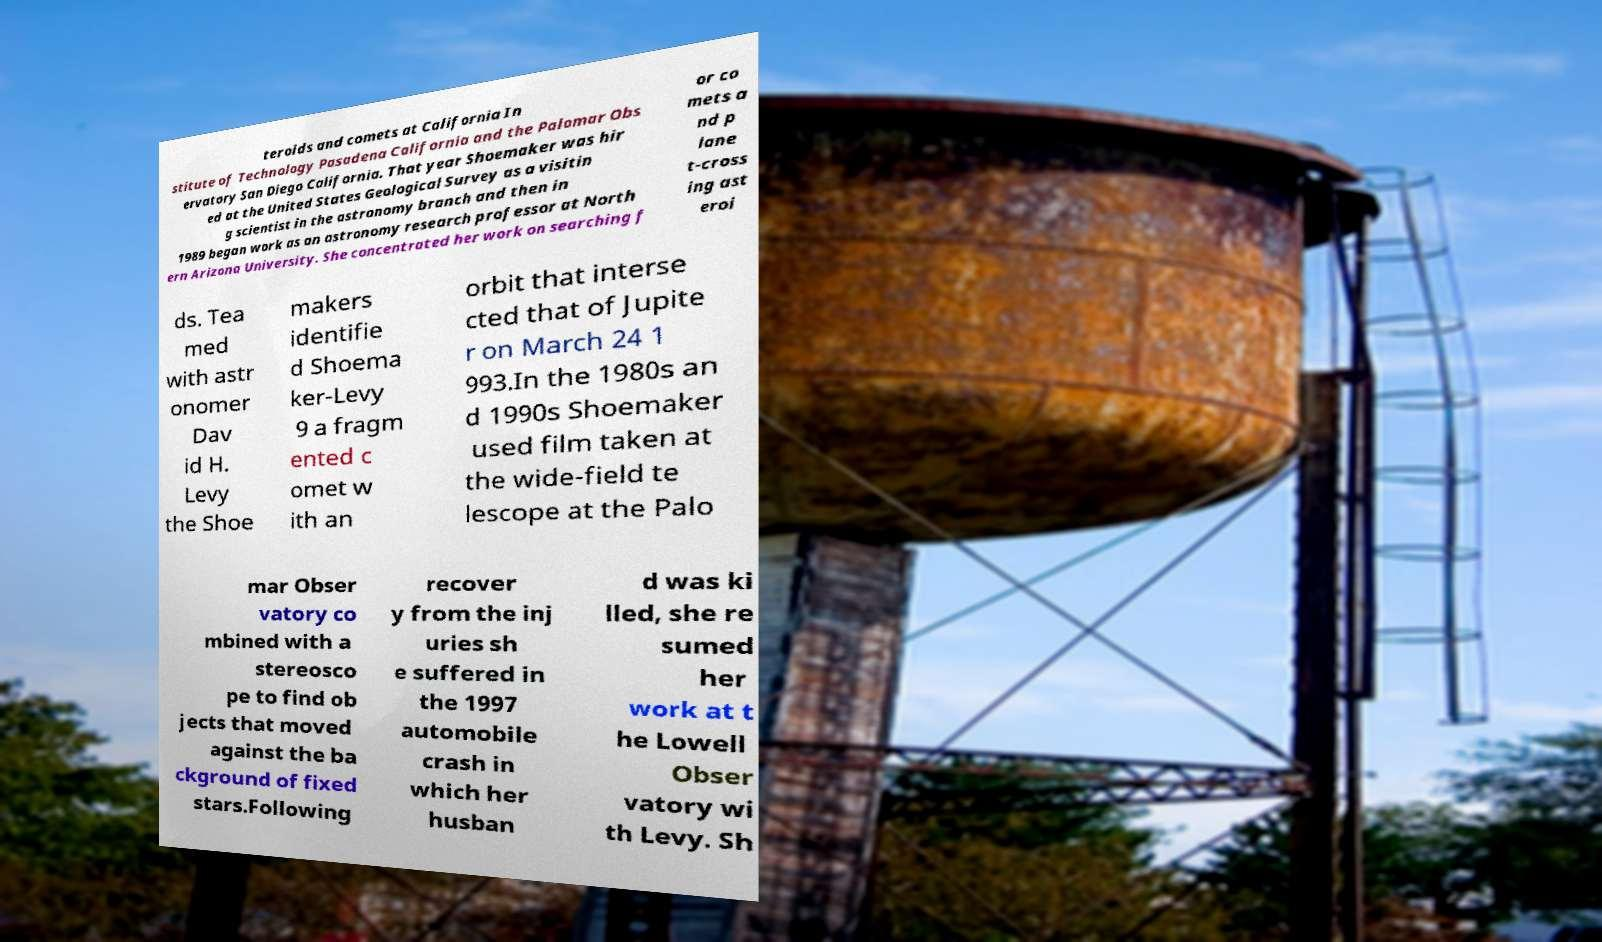Can you read and provide the text displayed in the image?This photo seems to have some interesting text. Can you extract and type it out for me? teroids and comets at California In stitute of Technology Pasadena California and the Palomar Obs ervatory San Diego California. That year Shoemaker was hir ed at the United States Geological Survey as a visitin g scientist in the astronomy branch and then in 1989 began work as an astronomy research professor at North ern Arizona University. She concentrated her work on searching f or co mets a nd p lane t-cross ing ast eroi ds. Tea med with astr onomer Dav id H. Levy the Shoe makers identifie d Shoema ker-Levy 9 a fragm ented c omet w ith an orbit that interse cted that of Jupite r on March 24 1 993.In the 1980s an d 1990s Shoemaker used film taken at the wide-field te lescope at the Palo mar Obser vatory co mbined with a stereosco pe to find ob jects that moved against the ba ckground of fixed stars.Following recover y from the inj uries sh e suffered in the 1997 automobile crash in which her husban d was ki lled, she re sumed her work at t he Lowell Obser vatory wi th Levy. Sh 